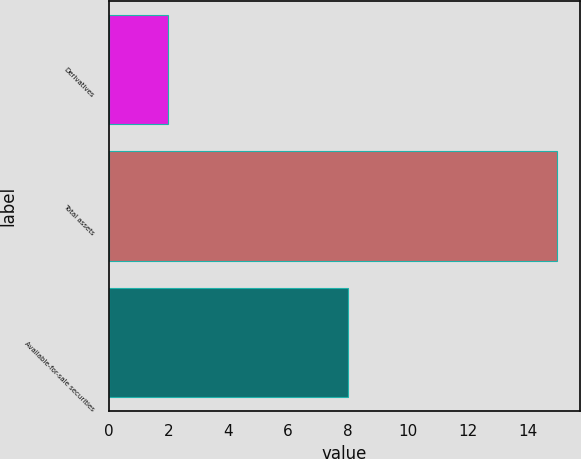<chart> <loc_0><loc_0><loc_500><loc_500><bar_chart><fcel>Derivatives<fcel>Total assets<fcel>Available-for-sale securities<nl><fcel>2<fcel>15<fcel>8<nl></chart> 